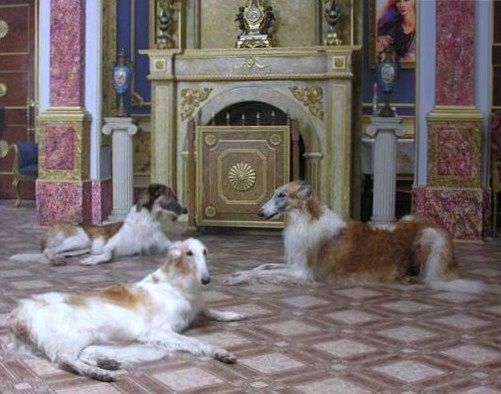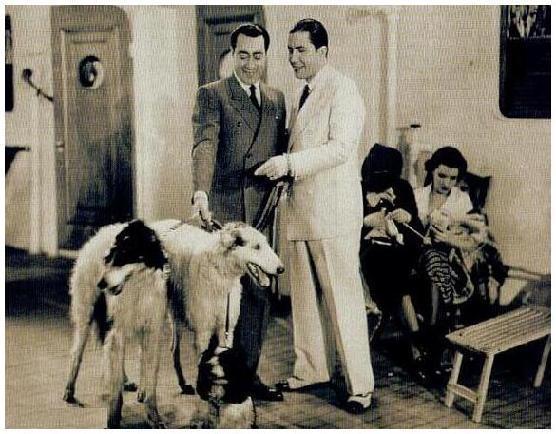The first image is the image on the left, the second image is the image on the right. Evaluate the accuracy of this statement regarding the images: "There are three dogs in the image pair.". Is it true? Answer yes or no. No. The first image is the image on the left, the second image is the image on the right. Considering the images on both sides, is "A lady wearing a long dress is with her dogs in at least one of the images." valid? Answer yes or no. No. 